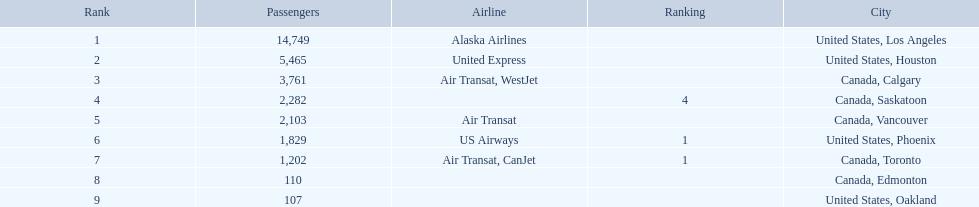Which cities had less than 2,000 passengers? United States, Phoenix, Canada, Toronto, Canada, Edmonton, United States, Oakland. Of these cities, which had fewer than 1,000 passengers? Canada, Edmonton, United States, Oakland. Of the cities in the previous answer, which one had only 107 passengers? United States, Oakland. 